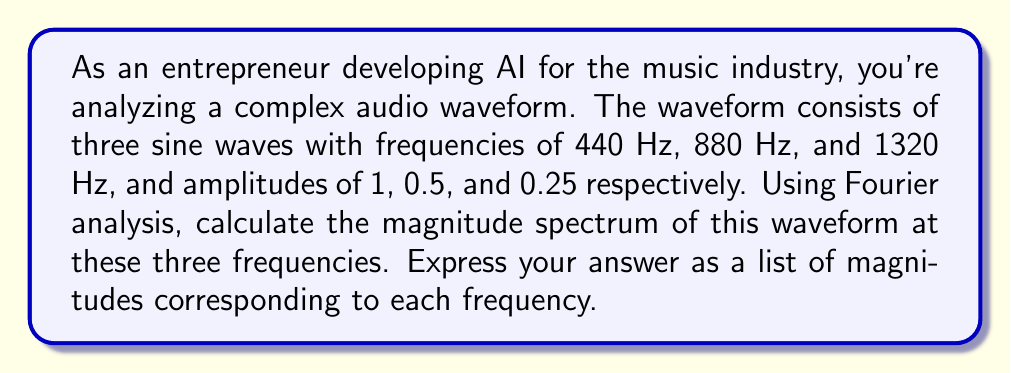Can you answer this question? To solve this problem, we'll follow these steps:

1) The given waveform can be expressed mathematically as:

   $$f(t) = 1 \sin(2\pi \cdot 440t) + 0.5 \sin(2\pi \cdot 880t) + 0.25 \sin(2\pi \cdot 1320t)$$

2) The Fourier transform of a sine wave with frequency $f_0$ and amplitude $A$ is given by:

   $$F(\omega) = \frac{A}{2i}[\delta(\omega - 2\pi f_0) - \delta(\omega + 2\pi f_0)]$$

   where $\delta$ is the Dirac delta function.

3) Using the linearity property of Fourier transforms, we can transform each component separately:

   For 440 Hz: $$F_1(\omega) = \frac{1}{2i}[\delta(\omega - 2\pi \cdot 440) - \delta(\omega + 2\pi \cdot 440)]$$
   For 880 Hz: $$F_2(\omega) = \frac{0.5}{2i}[\delta(\omega - 2\pi \cdot 880) - \delta(\omega + 2\pi \cdot 880)]$$
   For 1320 Hz: $$F_3(\omega) = \frac{0.25}{2i}[\delta(\omega - 2\pi \cdot 1320) - \delta(\omega + 2\pi \cdot 1320)]$$

4) The magnitude spectrum is given by the absolute value of the Fourier transform:

   At 440 Hz: $|F_1(2\pi \cdot 440)| = |\frac{1}{2i}| = 0.5$
   At 880 Hz: $|F_2(2\pi \cdot 880)| = |\frac{0.5}{2i}| = 0.25$
   At 1320 Hz: $|F_3(2\pi \cdot 1320)| = |\frac{0.25}{2i}| = 0.125$

5) The magnitude spectrum at these three frequencies is thus [0.5, 0.25, 0.125].
Answer: [0.5, 0.25, 0.125] 